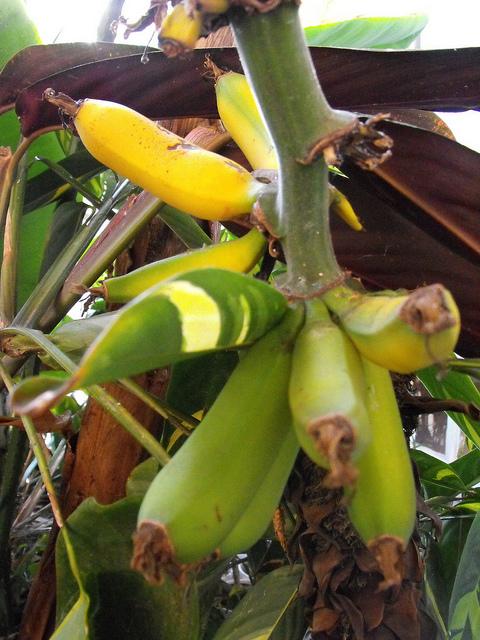How many pieces of fruit are on the tree?
Quick response, please. 9. Is the fruit ripe?
Quick response, please. No. What kind of fruit is shown?
Write a very short answer. Banana. 